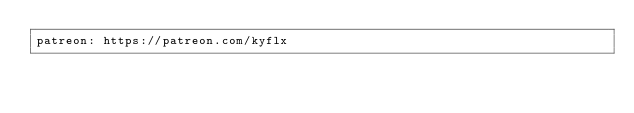Convert code to text. <code><loc_0><loc_0><loc_500><loc_500><_YAML_>patreon: https://patreon.com/kyflx
</code> 